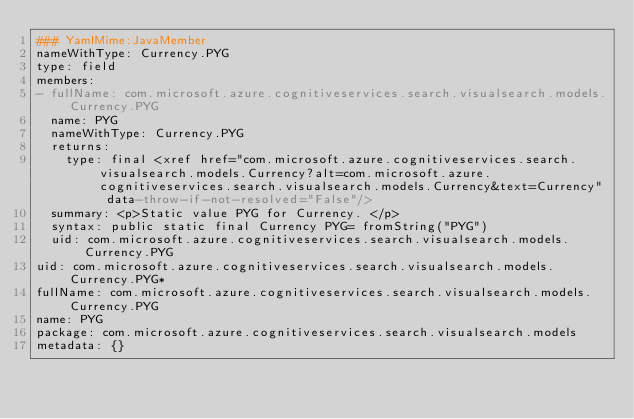<code> <loc_0><loc_0><loc_500><loc_500><_YAML_>### YamlMime:JavaMember
nameWithType: Currency.PYG
type: field
members:
- fullName: com.microsoft.azure.cognitiveservices.search.visualsearch.models.Currency.PYG
  name: PYG
  nameWithType: Currency.PYG
  returns:
    type: final <xref href="com.microsoft.azure.cognitiveservices.search.visualsearch.models.Currency?alt=com.microsoft.azure.cognitiveservices.search.visualsearch.models.Currency&text=Currency" data-throw-if-not-resolved="False"/>
  summary: <p>Static value PYG for Currency. </p>
  syntax: public static final Currency PYG= fromString("PYG")
  uid: com.microsoft.azure.cognitiveservices.search.visualsearch.models.Currency.PYG
uid: com.microsoft.azure.cognitiveservices.search.visualsearch.models.Currency.PYG*
fullName: com.microsoft.azure.cognitiveservices.search.visualsearch.models.Currency.PYG
name: PYG
package: com.microsoft.azure.cognitiveservices.search.visualsearch.models
metadata: {}
</code> 